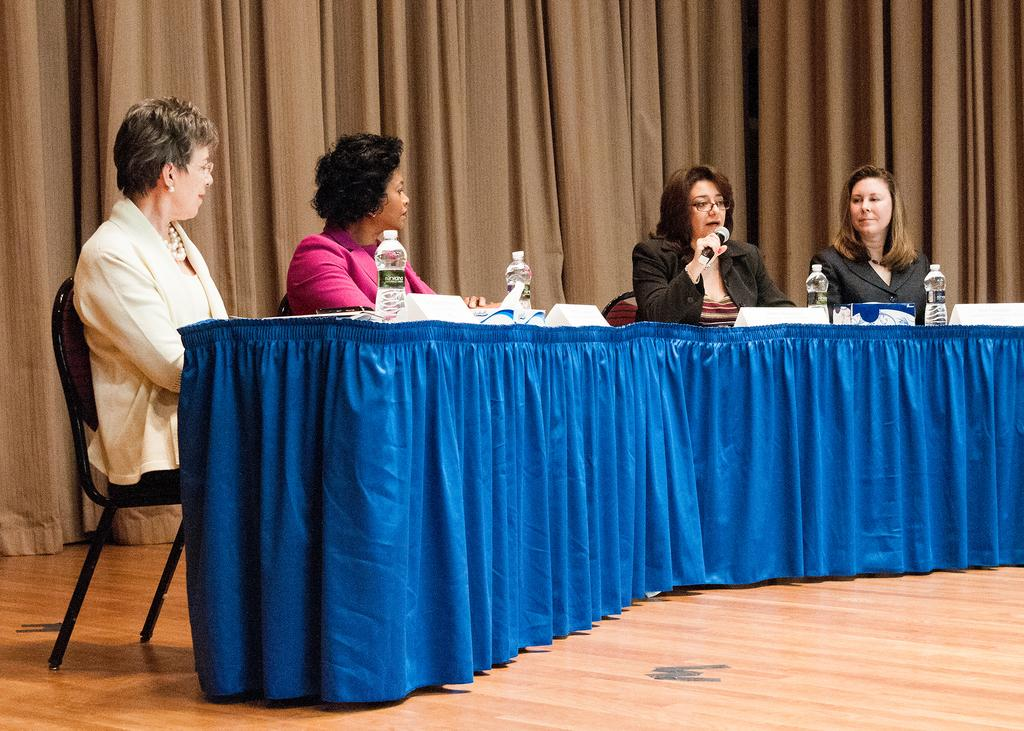How many women are in the image? There are five women in the image. Where are the women seated? The women are seated on a dais. What is located in front of the dais? There is a table in front of the dais. What can be found on the table? Water bottles are present on the table. What is the third woman doing? The third woman is holding a microphone. What type of belief is being discussed by the women in the image? There is no indication in the image of any specific belief being discussed. 